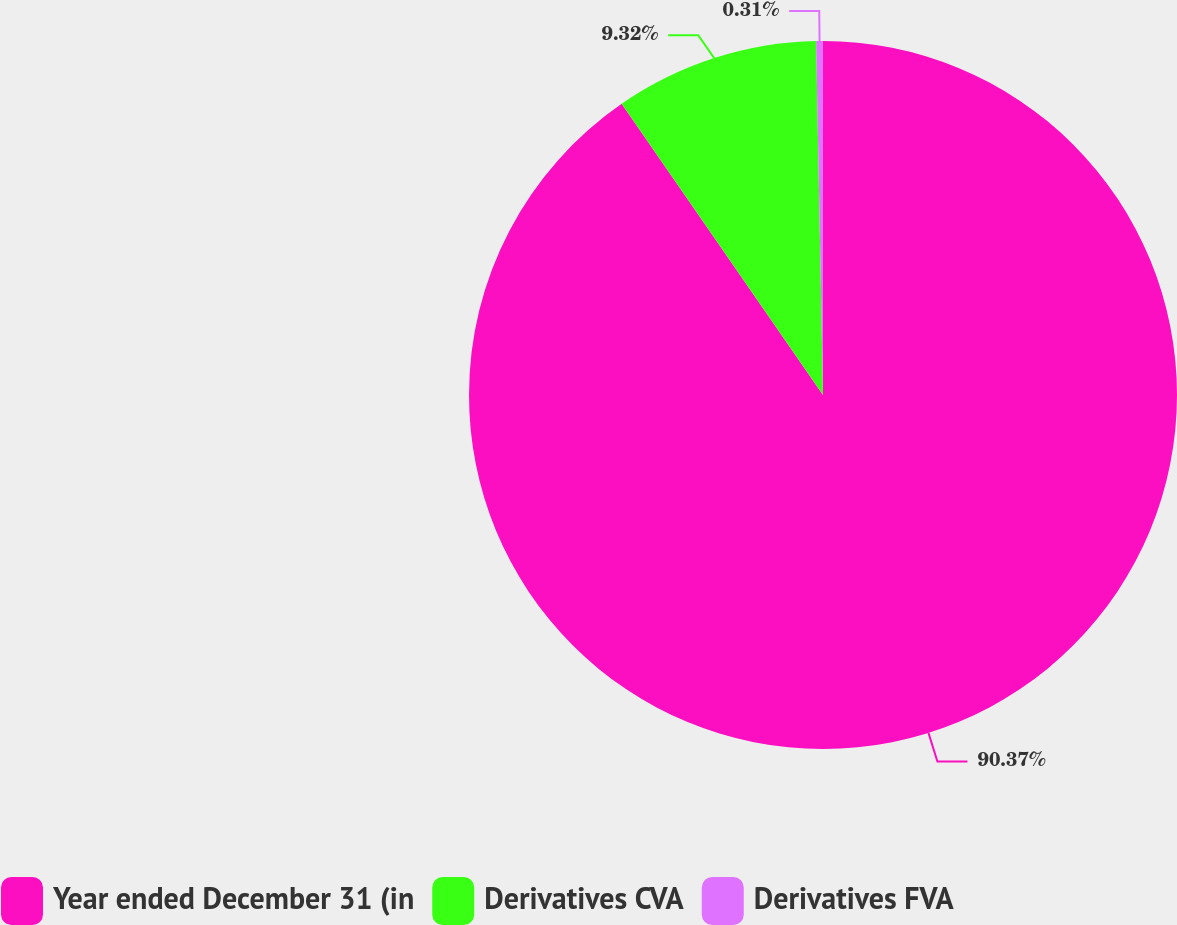<chart> <loc_0><loc_0><loc_500><loc_500><pie_chart><fcel>Year ended December 31 (in<fcel>Derivatives CVA<fcel>Derivatives FVA<nl><fcel>90.37%<fcel>9.32%<fcel>0.31%<nl></chart> 